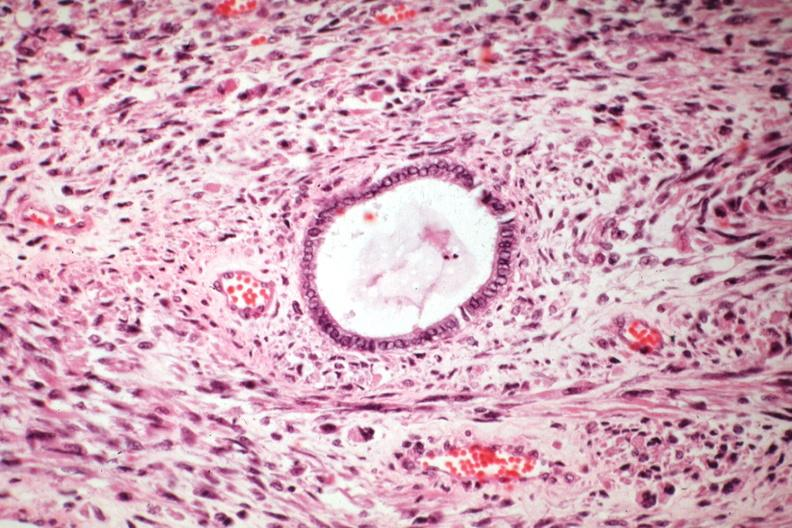s mixed mesodermal tumor present?
Answer the question using a single word or phrase. Yes 